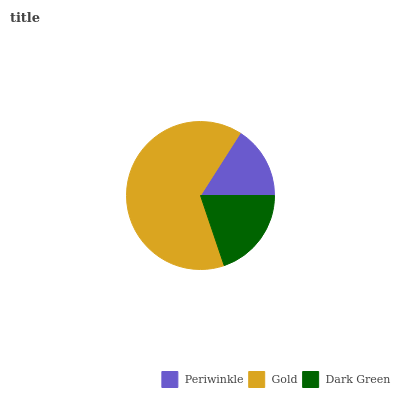Is Periwinkle the minimum?
Answer yes or no. Yes. Is Gold the maximum?
Answer yes or no. Yes. Is Dark Green the minimum?
Answer yes or no. No. Is Dark Green the maximum?
Answer yes or no. No. Is Gold greater than Dark Green?
Answer yes or no. Yes. Is Dark Green less than Gold?
Answer yes or no. Yes. Is Dark Green greater than Gold?
Answer yes or no. No. Is Gold less than Dark Green?
Answer yes or no. No. Is Dark Green the high median?
Answer yes or no. Yes. Is Dark Green the low median?
Answer yes or no. Yes. Is Gold the high median?
Answer yes or no. No. Is Gold the low median?
Answer yes or no. No. 